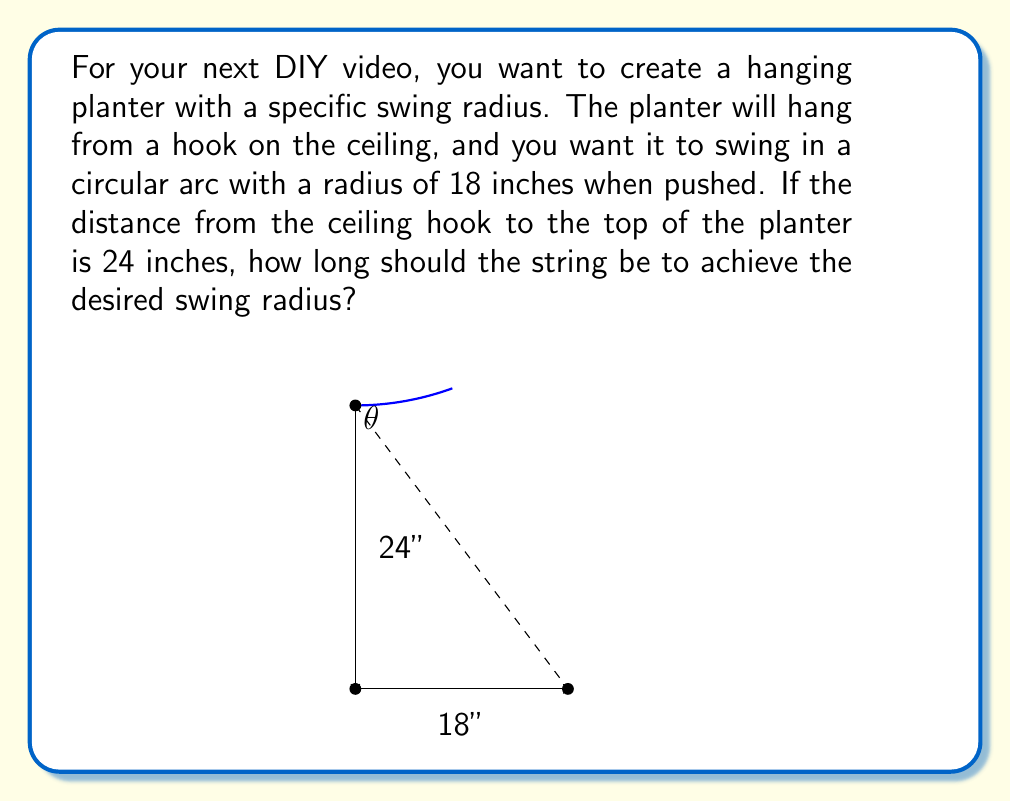Show me your answer to this math problem. Let's approach this step-by-step using trigonometry:

1) First, we need to recognize that this forms a right triangle. The string length is the hypotenuse, the swing radius is the base, and the vertical distance from the ceiling to the planter is the height.

2) We can use the Pythagorean theorem to find the length of the string. Let's call the string length $x$.

   $$x^2 = 24^2 + 18^2$$

3) Now, let's solve for $x$:
   
   $$x^2 = 576 + 324 = 900$$
   $$x = \sqrt{900} = 30$$

4) Therefore, the string needs to be 30 inches long.

5) We can verify this using trigonometry. The angle $\theta$ between the string and the vertical can be found using:

   $$\sin(\theta) = \frac{18}{30} = 0.6$$
   $$\theta = \arcsin(0.6) \approx 36.87°$$

6) Now, using this angle, we can confirm the vertical distance:

   $$\cos(\theta) = \frac{24}{30} = 0.8$$

   Which is indeed correct.

This solution ensures that when the planter swings, it will move in an arc with the desired 18-inch radius.
Answer: The string should be 30 inches long. 